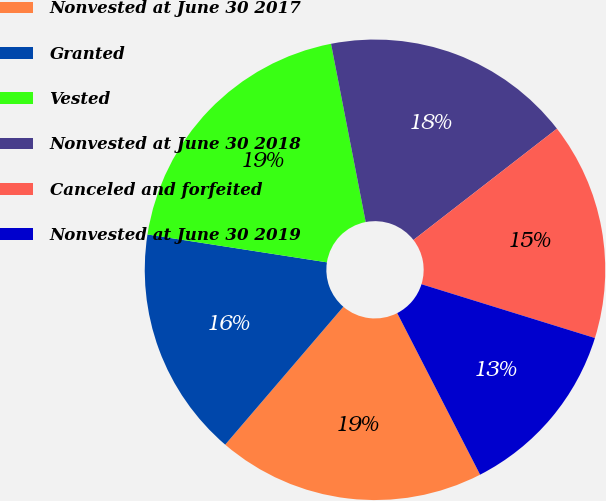Convert chart to OTSL. <chart><loc_0><loc_0><loc_500><loc_500><pie_chart><fcel>Nonvested at June 30 2017<fcel>Granted<fcel>Vested<fcel>Nonvested at June 30 2018<fcel>Canceled and forfeited<fcel>Nonvested at June 30 2019<nl><fcel>18.82%<fcel>16.18%<fcel>19.49%<fcel>17.56%<fcel>15.29%<fcel>12.67%<nl></chart> 